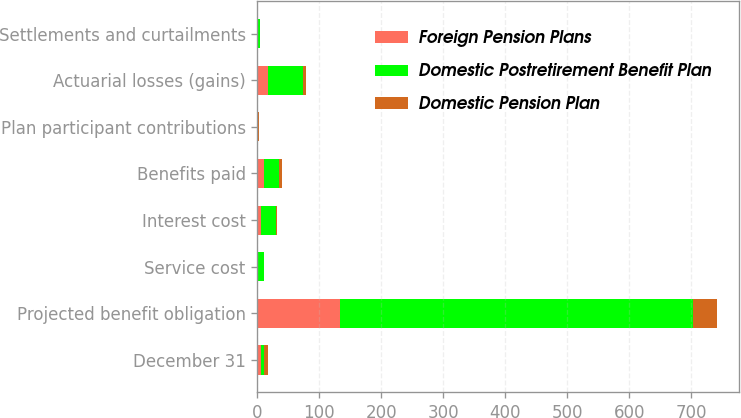Convert chart to OTSL. <chart><loc_0><loc_0><loc_500><loc_500><stacked_bar_chart><ecel><fcel>December 31<fcel>Projected benefit obligation<fcel>Service cost<fcel>Interest cost<fcel>Benefits paid<fcel>Plan participant contributions<fcel>Actuarial losses (gains)<fcel>Settlements and curtailments<nl><fcel>Foreign Pension Plans<fcel>5.6<fcel>133.1<fcel>0<fcel>6.2<fcel>10.4<fcel>0<fcel>18<fcel>0<nl><fcel>Domestic Postretirement Benefit Plan<fcel>5.6<fcel>569.9<fcel>10.3<fcel>23.4<fcel>24.1<fcel>0.6<fcel>55.7<fcel>4<nl><fcel>Domestic Pension Plan<fcel>5.6<fcel>37.9<fcel>0.1<fcel>1.7<fcel>5.6<fcel>1.5<fcel>4.4<fcel>0<nl></chart> 